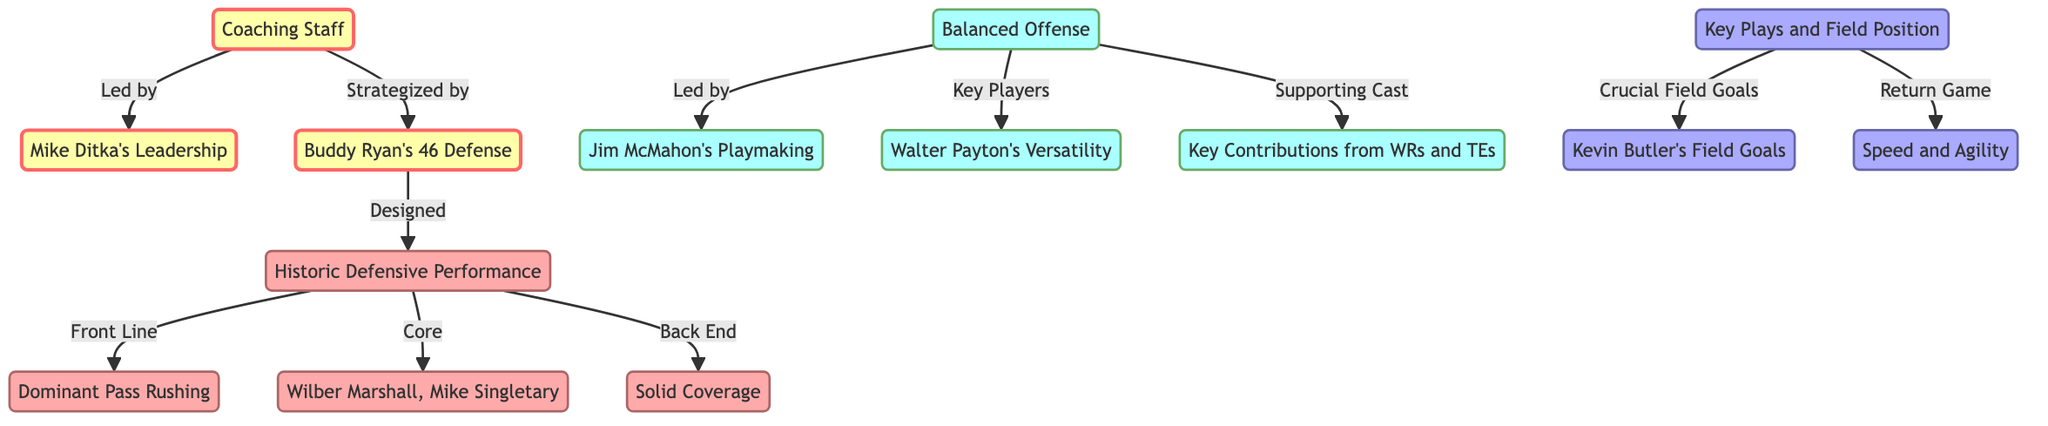What is the primary role of Mike Ditka in the coaching staff? Mike Ditka is the head coach, indicated by his direct connection from the coaching staff node, suggesting he leads and manages the team's strategies.
Answer: Head Coach Who is associated with the design of the 46 Defense strategy? The defensive coordinator, Buddy Ryan, is specifically linked to the design of the defense as indicated by the directional arrow from defensive coordinator to defense.
Answer: Buddy Ryan What positions do Wilber Marshall and Mike Singletary hold in the defense structure? They are categorized as linebackers, which is specified by their direct association under the defense node labeled as "Core".
Answer: Linebackers How does Jim McMahon contribute to the offense? Jim McMahon is identified as the quarterback, leading the offense, as per the node labeled "Led by" that connects offense to quarterback.
Answer: Playmaking What specific contributions do the return specialists provide to the special teams? The return specialists are noted for their speed and agility, as indicated by their labeling under the special teams node.
Answer: Speed and Agility How many distinct areas contribute to the overall success of the Chicago Bears' 1985 victory based on this diagram? There are four primary areas identified: Coaching Staff, Defense, Offense, and Special Teams, making a total of four areas contributing to success.
Answer: Four What role does Walter Payton play in the offense? Walter Payton’s role is described as providing versatility, which connects him directly to the offense as a key player.
Answer: Versatility What is the function of Kevin Butler in the diagram? Kevin Butler is specifically noted for his field goals, indicating his crucial role in scoring for the special teams unit.
Answer: Field Goals What aspect does the term "Dominant Pass Rushing" refer to in the diagram? This term relates to the defensive line, indicating a focus on applying pressure on the opposing quarterback, as shown in the defense node.
Answer: Defensive Line 